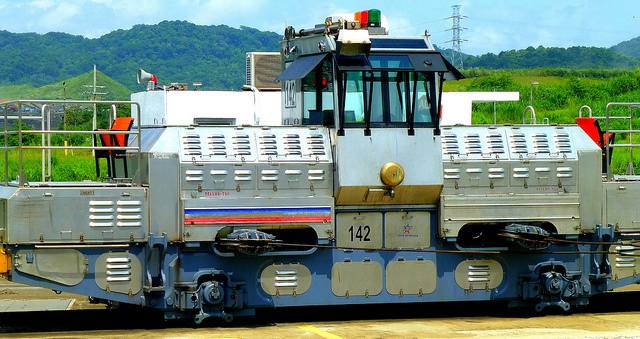Describe the objects in this image and their specific colors. I can see train in lightblue, black, darkgray, and gray tones, chair in lightblue, black, red, and brown tones, and chair in lightblue, red, black, gray, and brown tones in this image. 